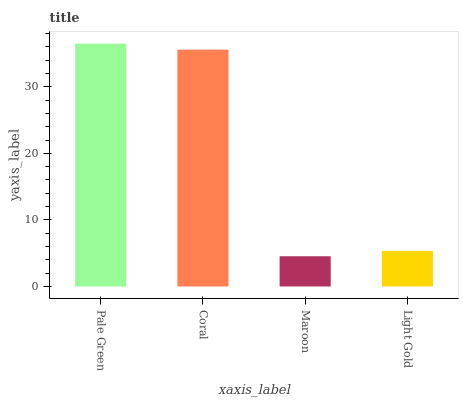Is Maroon the minimum?
Answer yes or no. Yes. Is Pale Green the maximum?
Answer yes or no. Yes. Is Coral the minimum?
Answer yes or no. No. Is Coral the maximum?
Answer yes or no. No. Is Pale Green greater than Coral?
Answer yes or no. Yes. Is Coral less than Pale Green?
Answer yes or no. Yes. Is Coral greater than Pale Green?
Answer yes or no. No. Is Pale Green less than Coral?
Answer yes or no. No. Is Coral the high median?
Answer yes or no. Yes. Is Light Gold the low median?
Answer yes or no. Yes. Is Light Gold the high median?
Answer yes or no. No. Is Maroon the low median?
Answer yes or no. No. 